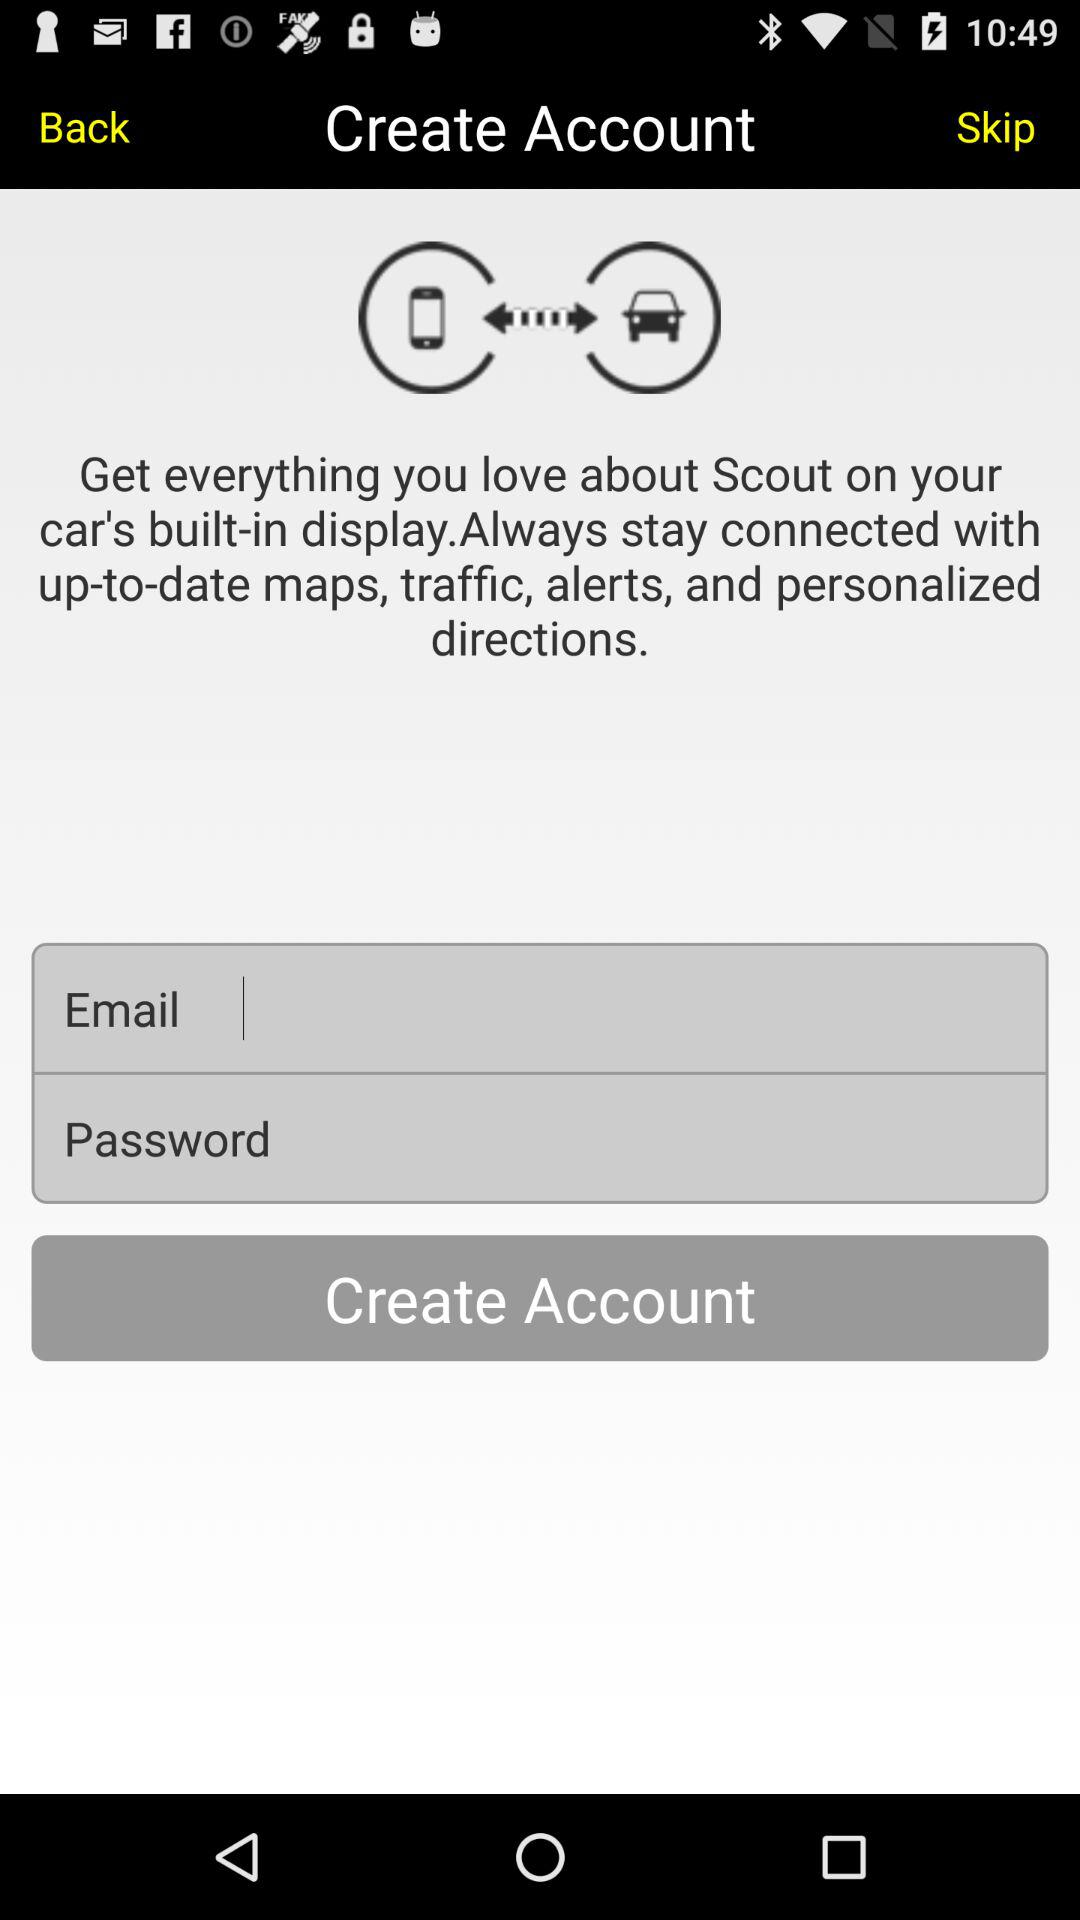What are the requirements to create an account? The requirements are "Email" and "Password". 